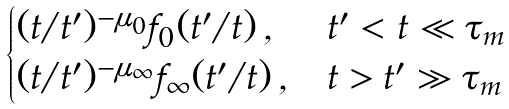<formula> <loc_0><loc_0><loc_500><loc_500>\begin{cases} ( t / t ^ { \prime } ) ^ { - \mu _ { 0 } } f _ { 0 } ( t ^ { \prime } / t ) \, , & t ^ { \prime } < t \ll \tau _ { m } \\ ( t / t ^ { \prime } ) ^ { - \mu _ { \infty } } f _ { \infty } ( t ^ { \prime } / t ) \, , & t > t ^ { \prime } \gg \tau _ { m } \end{cases}</formula> 